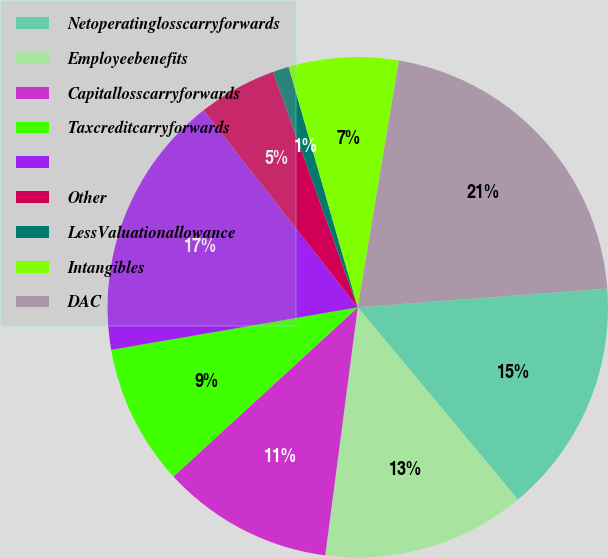Convert chart. <chart><loc_0><loc_0><loc_500><loc_500><pie_chart><fcel>Netoperatinglosscarryforwards<fcel>Employeebenefits<fcel>Capitallosscarryforwards<fcel>Taxcreditcarryforwards<fcel>Unnamed: 4<fcel>Other<fcel>LessValuationallowance<fcel>Intangibles<fcel>DAC<nl><fcel>15.14%<fcel>13.13%<fcel>11.11%<fcel>9.1%<fcel>17.16%<fcel>5.07%<fcel>1.04%<fcel>7.08%<fcel>21.19%<nl></chart> 